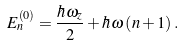<formula> <loc_0><loc_0><loc_500><loc_500>E _ { n } ^ { \left ( 0 \right ) } = \frac { \hbar { \omega } _ { z } } { 2 } + \hbar { \omega } \left ( n + 1 \right ) .</formula> 